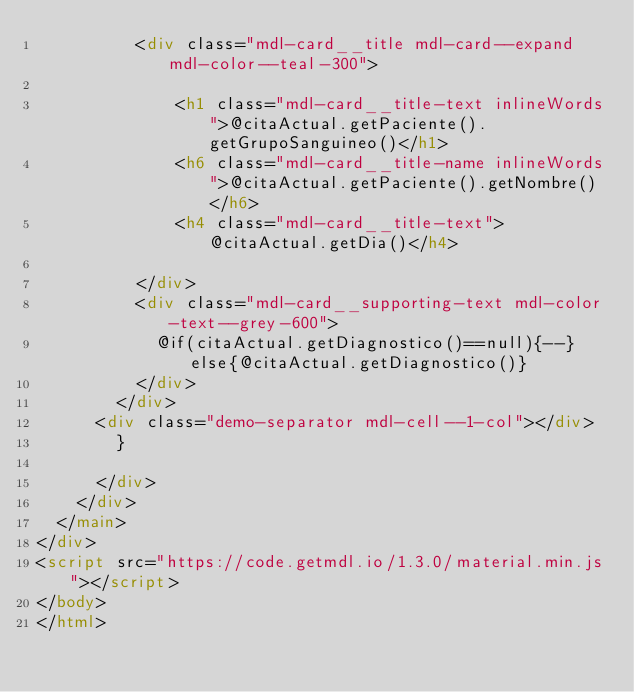<code> <loc_0><loc_0><loc_500><loc_500><_HTML_>          <div class="mdl-card__title mdl-card--expand mdl-color--teal-300">

              <h1 class="mdl-card__title-text inlineWords">@citaActual.getPaciente().getGrupoSanguineo()</h1>
              <h6 class="mdl-card__title-name inlineWords">@citaActual.getPaciente().getNombre()</h6>
              <h4 class="mdl-card__title-text">@citaActual.getDia()</h4>

          </div>
          <div class="mdl-card__supporting-text mdl-color-text--grey-600">
            @if(citaActual.getDiagnostico()==null){--}else{@citaActual.getDiagnostico()}
          </div>
        </div>
      <div class="demo-separator mdl-cell--1-col"></div>
        }

      </div>
    </div>
  </main>
</div>
<script src="https://code.getmdl.io/1.3.0/material.min.js"></script>
</body>
</html>
</code> 